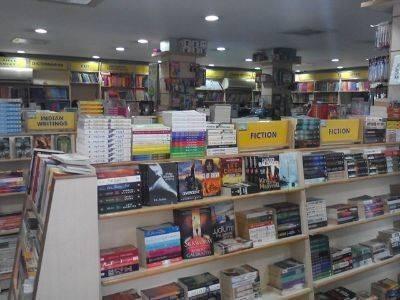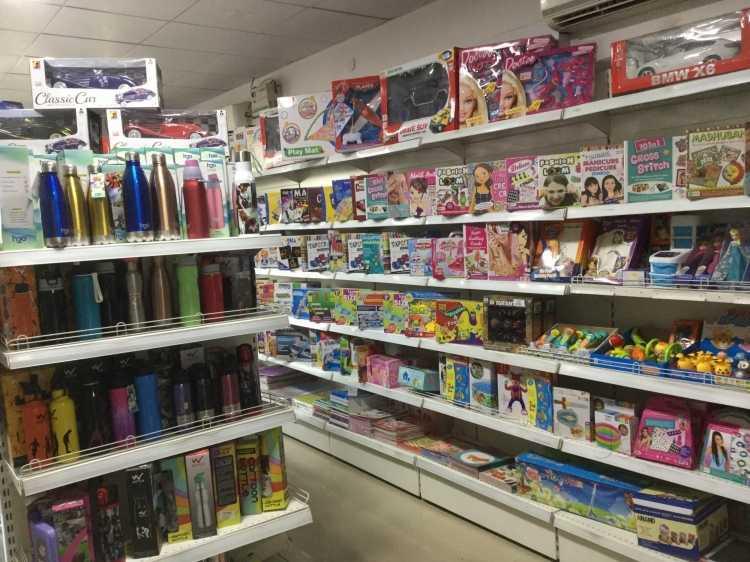The first image is the image on the left, the second image is the image on the right. For the images displayed, is the sentence "There are people and books." factually correct? Answer yes or no. No. The first image is the image on the left, the second image is the image on the right. Given the left and right images, does the statement "In at  least one image there is a single man with black hair and brown skin in a button up shirt surrounded by at least 100 books." hold true? Answer yes or no. No. 